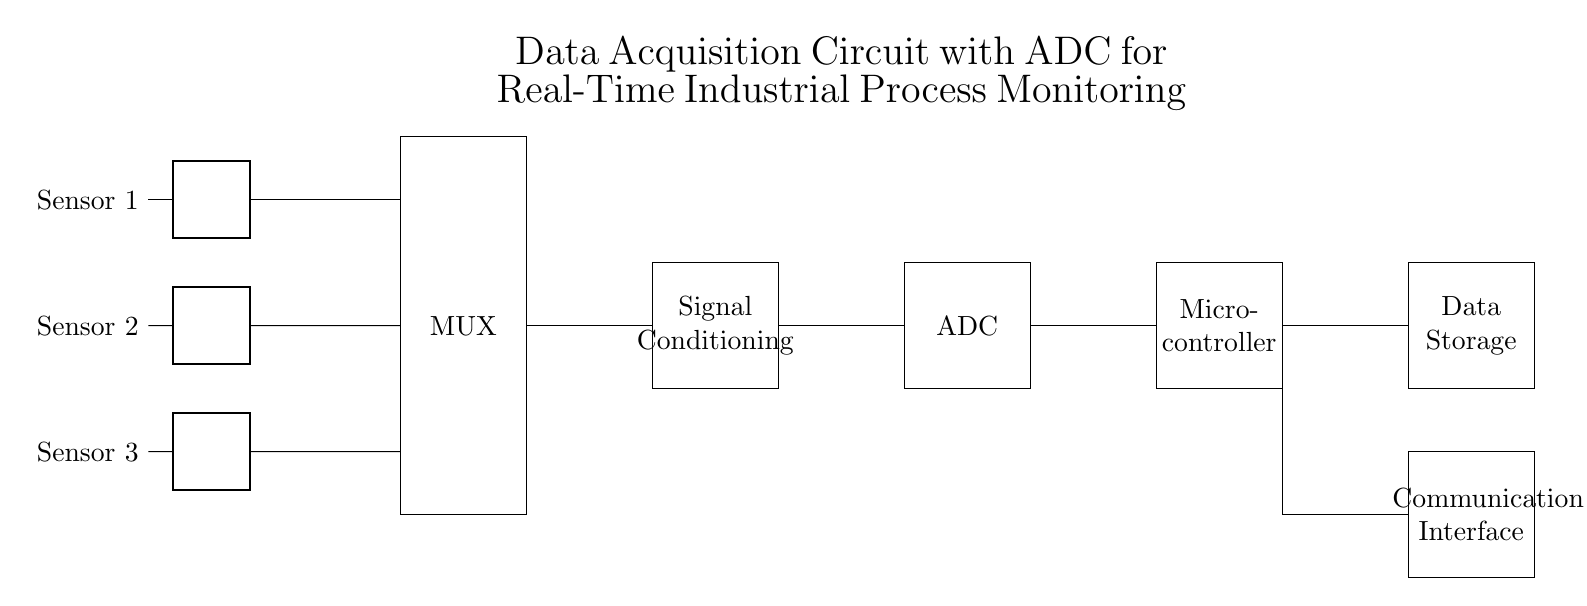What type of sensors are used? The circuit diagram shows three sensors labeled as Sensor 1, Sensor 2, and Sensor 3. These typically measure different parameters of the industrial process being monitored.
Answer: three sensors What component is responsible for signal conditioning? The circuit includes a section labeled "Signal Conditioning," which indicates that this component processes the signals from the sensors before they are sent to the ADC.
Answer: Signal Conditioning What does ADC stand for? The diagram has a block labeled "ADC," which stands for Analog-to-Digital Converter, a crucial component for converting analog signals into digital data for processing.
Answer: Analog-to-Digital Converter How many main stages are in the data acquisition circuit? By examining the circuit, we can identify six distinguished regions or stages: Sensors, MUX, Signal Conditioning, ADC, Microcontroller, and Data Storage, indicating the main flow of data acquisition.
Answer: six stages What is the function of the multiplexer in this circuit? The MUX is connected to multiple sensors, allowing it to select one of several input signals to send to the signal conditioning stage based on control signals, thus ensuring that only one sensor's data is processed at a time.
Answer: select input signals Describe the flow of data in the circuit. The flow begins at the sensors, whose outputs are fed into a multiplexer. The selected signal from the MUX is conditioned, and then it passes through the ADC for digitization, followed by processing in the microcontroller, and finally stored in Data Storage.
Answer: sensors to MUX to conditioning to ADC to microcontroller to storage What kind of communication interface is implied in the diagram? The circuit includes a block labeled "Communication Interface," indicating this component is likely used for data transmission to external systems or devices, enabling communication with other devices in the industrial setup.
Answer: Communication Interface 